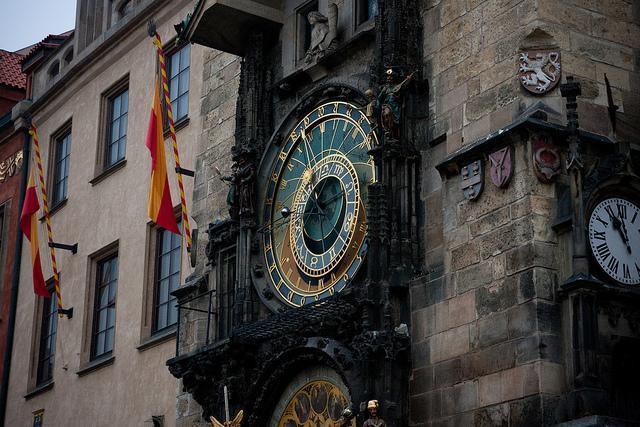How many flags?
Give a very brief answer. 2. How many clocks can you see?
Give a very brief answer. 2. 